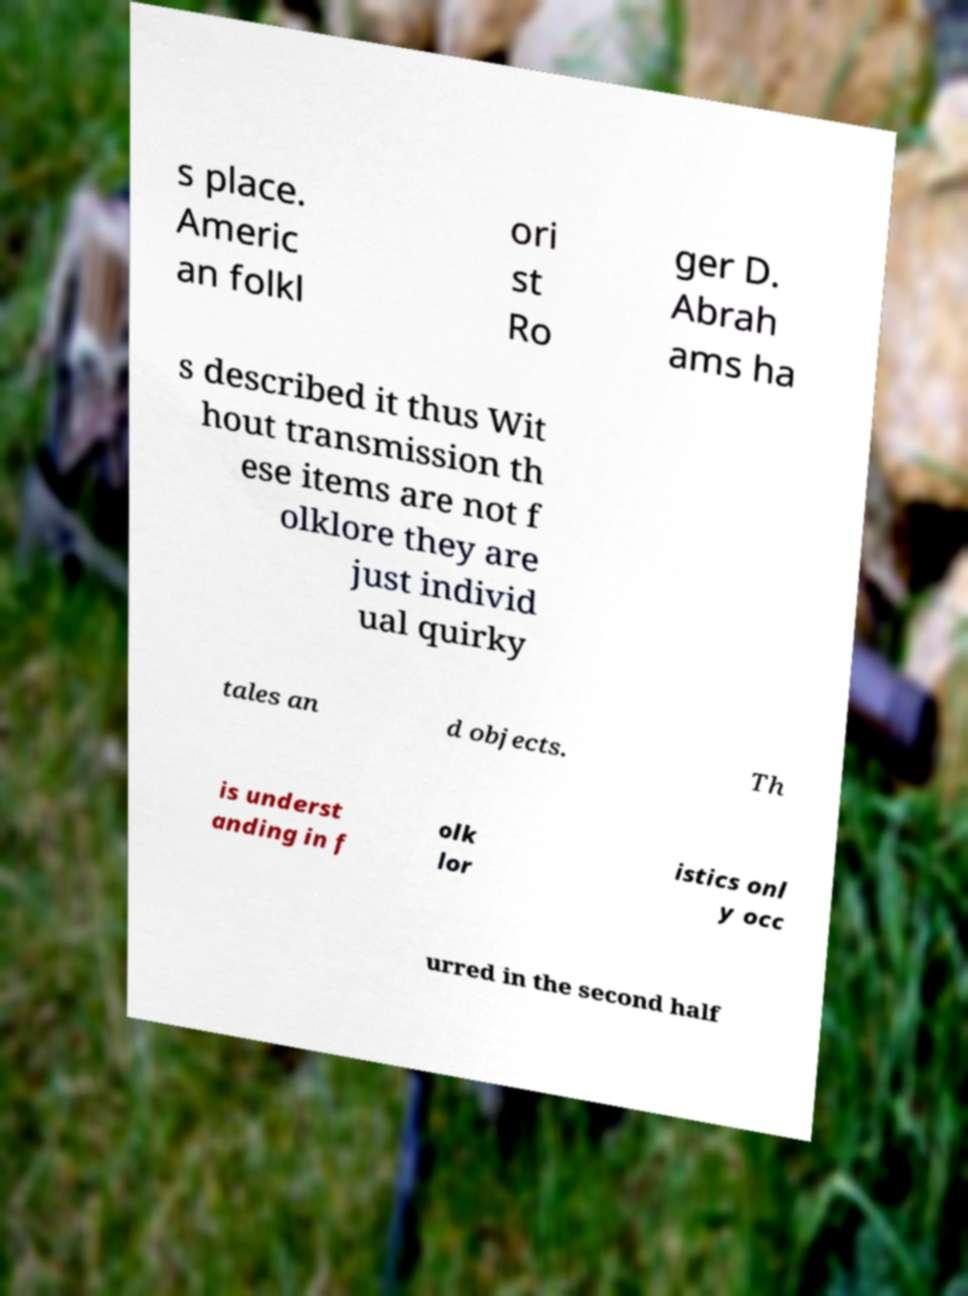Could you extract and type out the text from this image? s place. Americ an folkl ori st Ro ger D. Abrah ams ha s described it thus Wit hout transmission th ese items are not f olklore they are just individ ual quirky tales an d objects. Th is underst anding in f olk lor istics onl y occ urred in the second half 